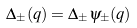Convert formula to latex. <formula><loc_0><loc_0><loc_500><loc_500>\Delta _ { \pm } ( { q } ) = \Delta _ { \pm } \psi _ { \pm } ( { q } )</formula> 